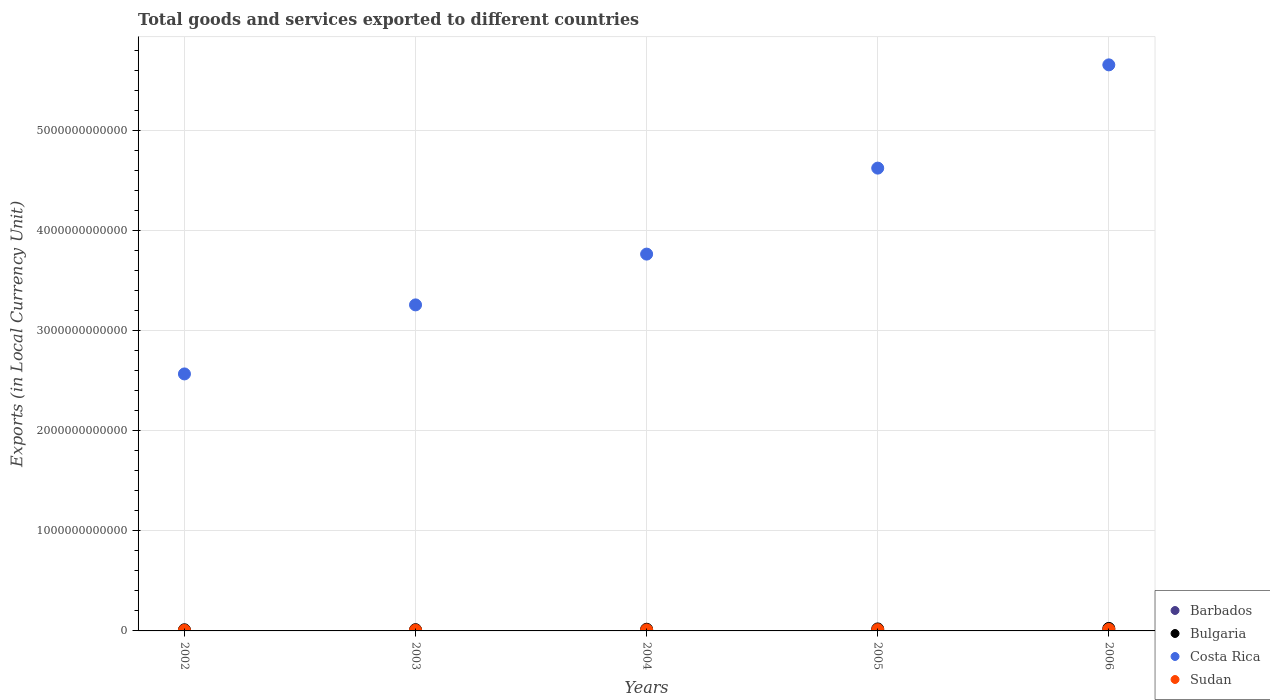Is the number of dotlines equal to the number of legend labels?
Your answer should be compact. Yes. What is the Amount of goods and services exports in Barbados in 2002?
Make the answer very short. 2.42e+09. Across all years, what is the maximum Amount of goods and services exports in Sudan?
Keep it short and to the point. 1.48e+1. Across all years, what is the minimum Amount of goods and services exports in Costa Rica?
Give a very brief answer. 2.57e+12. In which year was the Amount of goods and services exports in Bulgaria maximum?
Provide a succinct answer. 2006. What is the total Amount of goods and services exports in Barbados in the graph?
Offer a very short reply. 1.54e+1. What is the difference between the Amount of goods and services exports in Costa Rica in 2002 and that in 2006?
Keep it short and to the point. -3.09e+12. What is the difference between the Amount of goods and services exports in Costa Rica in 2006 and the Amount of goods and services exports in Bulgaria in 2003?
Your answer should be compact. 5.65e+12. What is the average Amount of goods and services exports in Sudan per year?
Your response must be concise. 9.87e+09. In the year 2004, what is the difference between the Amount of goods and services exports in Bulgaria and Amount of goods and services exports in Barbados?
Keep it short and to the point. 1.40e+1. What is the ratio of the Amount of goods and services exports in Bulgaria in 2005 to that in 2006?
Provide a succinct answer. 0.79. Is the Amount of goods and services exports in Sudan in 2005 less than that in 2006?
Your answer should be very brief. Yes. What is the difference between the highest and the second highest Amount of goods and services exports in Costa Rica?
Your answer should be compact. 1.03e+12. What is the difference between the highest and the lowest Amount of goods and services exports in Bulgaria?
Keep it short and to the point. 1.37e+1. In how many years, is the Amount of goods and services exports in Sudan greater than the average Amount of goods and services exports in Sudan taken over all years?
Your answer should be very brief. 2. Is it the case that in every year, the sum of the Amount of goods and services exports in Bulgaria and Amount of goods and services exports in Barbados  is greater than the sum of Amount of goods and services exports in Costa Rica and Amount of goods and services exports in Sudan?
Your answer should be very brief. Yes. Does the Amount of goods and services exports in Barbados monotonically increase over the years?
Make the answer very short. Yes. Is the Amount of goods and services exports in Sudan strictly greater than the Amount of goods and services exports in Costa Rica over the years?
Give a very brief answer. No. Is the Amount of goods and services exports in Barbados strictly less than the Amount of goods and services exports in Sudan over the years?
Offer a terse response. Yes. How many dotlines are there?
Ensure brevity in your answer.  4. What is the difference between two consecutive major ticks on the Y-axis?
Your response must be concise. 1.00e+12. Are the values on the major ticks of Y-axis written in scientific E-notation?
Your response must be concise. No. Does the graph contain any zero values?
Provide a short and direct response. No. Does the graph contain grids?
Ensure brevity in your answer.  Yes. Where does the legend appear in the graph?
Your answer should be very brief. Bottom right. How many legend labels are there?
Provide a short and direct response. 4. What is the title of the graph?
Your answer should be very brief. Total goods and services exported to different countries. Does "Isle of Man" appear as one of the legend labels in the graph?
Offer a very short reply. No. What is the label or title of the X-axis?
Keep it short and to the point. Years. What is the label or title of the Y-axis?
Give a very brief answer. Exports (in Local Currency Unit). What is the Exports (in Local Currency Unit) in Barbados in 2002?
Make the answer very short. 2.42e+09. What is the Exports (in Local Currency Unit) in Bulgaria in 2002?
Keep it short and to the point. 1.15e+1. What is the Exports (in Local Currency Unit) of Costa Rica in 2002?
Ensure brevity in your answer.  2.57e+12. What is the Exports (in Local Currency Unit) in Sudan in 2002?
Keep it short and to the point. 5.45e+09. What is the Exports (in Local Currency Unit) of Barbados in 2003?
Offer a very short reply. 2.76e+09. What is the Exports (in Local Currency Unit) in Bulgaria in 2003?
Offer a terse response. 1.26e+1. What is the Exports (in Local Currency Unit) of Costa Rica in 2003?
Your response must be concise. 3.26e+12. What is the Exports (in Local Currency Unit) of Sudan in 2003?
Your answer should be very brief. 6.83e+09. What is the Exports (in Local Currency Unit) of Barbados in 2004?
Provide a succinct answer. 2.87e+09. What is the Exports (in Local Currency Unit) of Bulgaria in 2004?
Keep it short and to the point. 1.69e+1. What is the Exports (in Local Currency Unit) in Costa Rica in 2004?
Keep it short and to the point. 3.77e+12. What is the Exports (in Local Currency Unit) in Sudan in 2004?
Offer a very short reply. 9.83e+09. What is the Exports (in Local Currency Unit) in Barbados in 2005?
Keep it short and to the point. 3.42e+09. What is the Exports (in Local Currency Unit) of Bulgaria in 2005?
Offer a very short reply. 2.00e+1. What is the Exports (in Local Currency Unit) of Costa Rica in 2005?
Provide a short and direct response. 4.63e+12. What is the Exports (in Local Currency Unit) in Sudan in 2005?
Ensure brevity in your answer.  1.24e+1. What is the Exports (in Local Currency Unit) of Barbados in 2006?
Keep it short and to the point. 3.88e+09. What is the Exports (in Local Currency Unit) in Bulgaria in 2006?
Your response must be concise. 2.52e+1. What is the Exports (in Local Currency Unit) of Costa Rica in 2006?
Ensure brevity in your answer.  5.66e+12. What is the Exports (in Local Currency Unit) of Sudan in 2006?
Make the answer very short. 1.48e+1. Across all years, what is the maximum Exports (in Local Currency Unit) of Barbados?
Your answer should be very brief. 3.88e+09. Across all years, what is the maximum Exports (in Local Currency Unit) in Bulgaria?
Your answer should be very brief. 2.52e+1. Across all years, what is the maximum Exports (in Local Currency Unit) in Costa Rica?
Give a very brief answer. 5.66e+12. Across all years, what is the maximum Exports (in Local Currency Unit) of Sudan?
Keep it short and to the point. 1.48e+1. Across all years, what is the minimum Exports (in Local Currency Unit) in Barbados?
Your answer should be compact. 2.42e+09. Across all years, what is the minimum Exports (in Local Currency Unit) in Bulgaria?
Provide a short and direct response. 1.15e+1. Across all years, what is the minimum Exports (in Local Currency Unit) in Costa Rica?
Your answer should be compact. 2.57e+12. Across all years, what is the minimum Exports (in Local Currency Unit) in Sudan?
Provide a short and direct response. 5.45e+09. What is the total Exports (in Local Currency Unit) in Barbados in the graph?
Make the answer very short. 1.54e+1. What is the total Exports (in Local Currency Unit) of Bulgaria in the graph?
Ensure brevity in your answer.  8.61e+1. What is the total Exports (in Local Currency Unit) of Costa Rica in the graph?
Your answer should be compact. 1.99e+13. What is the total Exports (in Local Currency Unit) in Sudan in the graph?
Ensure brevity in your answer.  4.93e+1. What is the difference between the Exports (in Local Currency Unit) of Barbados in 2002 and that in 2003?
Offer a very short reply. -3.36e+08. What is the difference between the Exports (in Local Currency Unit) in Bulgaria in 2002 and that in 2003?
Offer a terse response. -1.15e+09. What is the difference between the Exports (in Local Currency Unit) in Costa Rica in 2002 and that in 2003?
Your answer should be compact. -6.90e+11. What is the difference between the Exports (in Local Currency Unit) of Sudan in 2002 and that in 2003?
Provide a succinct answer. -1.38e+09. What is the difference between the Exports (in Local Currency Unit) in Barbados in 2002 and that in 2004?
Ensure brevity in your answer.  -4.50e+08. What is the difference between the Exports (in Local Currency Unit) in Bulgaria in 2002 and that in 2004?
Your response must be concise. -5.41e+09. What is the difference between the Exports (in Local Currency Unit) in Costa Rica in 2002 and that in 2004?
Keep it short and to the point. -1.20e+12. What is the difference between the Exports (in Local Currency Unit) in Sudan in 2002 and that in 2004?
Ensure brevity in your answer.  -4.38e+09. What is the difference between the Exports (in Local Currency Unit) of Barbados in 2002 and that in 2005?
Your answer should be very brief. -1.00e+09. What is the difference between the Exports (in Local Currency Unit) in Bulgaria in 2002 and that in 2005?
Make the answer very short. -8.53e+09. What is the difference between the Exports (in Local Currency Unit) in Costa Rica in 2002 and that in 2005?
Offer a terse response. -2.06e+12. What is the difference between the Exports (in Local Currency Unit) of Sudan in 2002 and that in 2005?
Your response must be concise. -6.94e+09. What is the difference between the Exports (in Local Currency Unit) of Barbados in 2002 and that in 2006?
Offer a very short reply. -1.46e+09. What is the difference between the Exports (in Local Currency Unit) of Bulgaria in 2002 and that in 2006?
Give a very brief answer. -1.37e+1. What is the difference between the Exports (in Local Currency Unit) of Costa Rica in 2002 and that in 2006?
Your answer should be very brief. -3.09e+12. What is the difference between the Exports (in Local Currency Unit) in Sudan in 2002 and that in 2006?
Provide a short and direct response. -9.39e+09. What is the difference between the Exports (in Local Currency Unit) in Barbados in 2003 and that in 2004?
Keep it short and to the point. -1.14e+08. What is the difference between the Exports (in Local Currency Unit) of Bulgaria in 2003 and that in 2004?
Your answer should be very brief. -4.27e+09. What is the difference between the Exports (in Local Currency Unit) in Costa Rica in 2003 and that in 2004?
Your answer should be very brief. -5.08e+11. What is the difference between the Exports (in Local Currency Unit) of Sudan in 2003 and that in 2004?
Offer a terse response. -3.00e+09. What is the difference between the Exports (in Local Currency Unit) of Barbados in 2003 and that in 2005?
Offer a terse response. -6.65e+08. What is the difference between the Exports (in Local Currency Unit) of Bulgaria in 2003 and that in 2005?
Offer a terse response. -7.39e+09. What is the difference between the Exports (in Local Currency Unit) of Costa Rica in 2003 and that in 2005?
Offer a very short reply. -1.37e+12. What is the difference between the Exports (in Local Currency Unit) of Sudan in 2003 and that in 2005?
Your answer should be compact. -5.56e+09. What is the difference between the Exports (in Local Currency Unit) of Barbados in 2003 and that in 2006?
Keep it short and to the point. -1.12e+09. What is the difference between the Exports (in Local Currency Unit) in Bulgaria in 2003 and that in 2006?
Your answer should be very brief. -1.26e+1. What is the difference between the Exports (in Local Currency Unit) of Costa Rica in 2003 and that in 2006?
Keep it short and to the point. -2.40e+12. What is the difference between the Exports (in Local Currency Unit) in Sudan in 2003 and that in 2006?
Your response must be concise. -8.01e+09. What is the difference between the Exports (in Local Currency Unit) in Barbados in 2004 and that in 2005?
Provide a succinct answer. -5.51e+08. What is the difference between the Exports (in Local Currency Unit) of Bulgaria in 2004 and that in 2005?
Your answer should be compact. -3.12e+09. What is the difference between the Exports (in Local Currency Unit) of Costa Rica in 2004 and that in 2005?
Offer a very short reply. -8.60e+11. What is the difference between the Exports (in Local Currency Unit) of Sudan in 2004 and that in 2005?
Provide a short and direct response. -2.56e+09. What is the difference between the Exports (in Local Currency Unit) of Barbados in 2004 and that in 2006?
Your answer should be compact. -1.00e+09. What is the difference between the Exports (in Local Currency Unit) in Bulgaria in 2004 and that in 2006?
Offer a very short reply. -8.31e+09. What is the difference between the Exports (in Local Currency Unit) of Costa Rica in 2004 and that in 2006?
Your answer should be compact. -1.89e+12. What is the difference between the Exports (in Local Currency Unit) of Sudan in 2004 and that in 2006?
Ensure brevity in your answer.  -5.01e+09. What is the difference between the Exports (in Local Currency Unit) of Barbados in 2005 and that in 2006?
Provide a succinct answer. -4.54e+08. What is the difference between the Exports (in Local Currency Unit) of Bulgaria in 2005 and that in 2006?
Provide a succinct answer. -5.19e+09. What is the difference between the Exports (in Local Currency Unit) of Costa Rica in 2005 and that in 2006?
Your response must be concise. -1.03e+12. What is the difference between the Exports (in Local Currency Unit) in Sudan in 2005 and that in 2006?
Keep it short and to the point. -2.44e+09. What is the difference between the Exports (in Local Currency Unit) of Barbados in 2002 and the Exports (in Local Currency Unit) of Bulgaria in 2003?
Keep it short and to the point. -1.02e+1. What is the difference between the Exports (in Local Currency Unit) in Barbados in 2002 and the Exports (in Local Currency Unit) in Costa Rica in 2003?
Provide a succinct answer. -3.26e+12. What is the difference between the Exports (in Local Currency Unit) of Barbados in 2002 and the Exports (in Local Currency Unit) of Sudan in 2003?
Your answer should be compact. -4.41e+09. What is the difference between the Exports (in Local Currency Unit) of Bulgaria in 2002 and the Exports (in Local Currency Unit) of Costa Rica in 2003?
Your answer should be compact. -3.25e+12. What is the difference between the Exports (in Local Currency Unit) in Bulgaria in 2002 and the Exports (in Local Currency Unit) in Sudan in 2003?
Your response must be concise. 4.63e+09. What is the difference between the Exports (in Local Currency Unit) of Costa Rica in 2002 and the Exports (in Local Currency Unit) of Sudan in 2003?
Provide a succinct answer. 2.56e+12. What is the difference between the Exports (in Local Currency Unit) in Barbados in 2002 and the Exports (in Local Currency Unit) in Bulgaria in 2004?
Make the answer very short. -1.45e+1. What is the difference between the Exports (in Local Currency Unit) of Barbados in 2002 and the Exports (in Local Currency Unit) of Costa Rica in 2004?
Offer a terse response. -3.76e+12. What is the difference between the Exports (in Local Currency Unit) of Barbados in 2002 and the Exports (in Local Currency Unit) of Sudan in 2004?
Provide a succinct answer. -7.41e+09. What is the difference between the Exports (in Local Currency Unit) of Bulgaria in 2002 and the Exports (in Local Currency Unit) of Costa Rica in 2004?
Your response must be concise. -3.76e+12. What is the difference between the Exports (in Local Currency Unit) in Bulgaria in 2002 and the Exports (in Local Currency Unit) in Sudan in 2004?
Ensure brevity in your answer.  1.64e+09. What is the difference between the Exports (in Local Currency Unit) in Costa Rica in 2002 and the Exports (in Local Currency Unit) in Sudan in 2004?
Provide a succinct answer. 2.56e+12. What is the difference between the Exports (in Local Currency Unit) of Barbados in 2002 and the Exports (in Local Currency Unit) of Bulgaria in 2005?
Provide a succinct answer. -1.76e+1. What is the difference between the Exports (in Local Currency Unit) in Barbados in 2002 and the Exports (in Local Currency Unit) in Costa Rica in 2005?
Provide a succinct answer. -4.62e+12. What is the difference between the Exports (in Local Currency Unit) in Barbados in 2002 and the Exports (in Local Currency Unit) in Sudan in 2005?
Provide a short and direct response. -9.97e+09. What is the difference between the Exports (in Local Currency Unit) in Bulgaria in 2002 and the Exports (in Local Currency Unit) in Costa Rica in 2005?
Offer a terse response. -4.61e+12. What is the difference between the Exports (in Local Currency Unit) of Bulgaria in 2002 and the Exports (in Local Currency Unit) of Sudan in 2005?
Make the answer very short. -9.29e+08. What is the difference between the Exports (in Local Currency Unit) in Costa Rica in 2002 and the Exports (in Local Currency Unit) in Sudan in 2005?
Offer a terse response. 2.56e+12. What is the difference between the Exports (in Local Currency Unit) in Barbados in 2002 and the Exports (in Local Currency Unit) in Bulgaria in 2006?
Provide a short and direct response. -2.28e+1. What is the difference between the Exports (in Local Currency Unit) in Barbados in 2002 and the Exports (in Local Currency Unit) in Costa Rica in 2006?
Make the answer very short. -5.66e+12. What is the difference between the Exports (in Local Currency Unit) of Barbados in 2002 and the Exports (in Local Currency Unit) of Sudan in 2006?
Keep it short and to the point. -1.24e+1. What is the difference between the Exports (in Local Currency Unit) of Bulgaria in 2002 and the Exports (in Local Currency Unit) of Costa Rica in 2006?
Offer a terse response. -5.65e+12. What is the difference between the Exports (in Local Currency Unit) of Bulgaria in 2002 and the Exports (in Local Currency Unit) of Sudan in 2006?
Keep it short and to the point. -3.37e+09. What is the difference between the Exports (in Local Currency Unit) in Costa Rica in 2002 and the Exports (in Local Currency Unit) in Sudan in 2006?
Keep it short and to the point. 2.55e+12. What is the difference between the Exports (in Local Currency Unit) of Barbados in 2003 and the Exports (in Local Currency Unit) of Bulgaria in 2004?
Offer a very short reply. -1.41e+1. What is the difference between the Exports (in Local Currency Unit) in Barbados in 2003 and the Exports (in Local Currency Unit) in Costa Rica in 2004?
Offer a very short reply. -3.76e+12. What is the difference between the Exports (in Local Currency Unit) of Barbados in 2003 and the Exports (in Local Currency Unit) of Sudan in 2004?
Provide a succinct answer. -7.07e+09. What is the difference between the Exports (in Local Currency Unit) in Bulgaria in 2003 and the Exports (in Local Currency Unit) in Costa Rica in 2004?
Offer a terse response. -3.75e+12. What is the difference between the Exports (in Local Currency Unit) in Bulgaria in 2003 and the Exports (in Local Currency Unit) in Sudan in 2004?
Your answer should be very brief. 2.78e+09. What is the difference between the Exports (in Local Currency Unit) of Costa Rica in 2003 and the Exports (in Local Currency Unit) of Sudan in 2004?
Ensure brevity in your answer.  3.25e+12. What is the difference between the Exports (in Local Currency Unit) in Barbados in 2003 and the Exports (in Local Currency Unit) in Bulgaria in 2005?
Keep it short and to the point. -1.72e+1. What is the difference between the Exports (in Local Currency Unit) in Barbados in 2003 and the Exports (in Local Currency Unit) in Costa Rica in 2005?
Your answer should be very brief. -4.62e+12. What is the difference between the Exports (in Local Currency Unit) in Barbados in 2003 and the Exports (in Local Currency Unit) in Sudan in 2005?
Keep it short and to the point. -9.63e+09. What is the difference between the Exports (in Local Currency Unit) in Bulgaria in 2003 and the Exports (in Local Currency Unit) in Costa Rica in 2005?
Your answer should be very brief. -4.61e+12. What is the difference between the Exports (in Local Currency Unit) of Bulgaria in 2003 and the Exports (in Local Currency Unit) of Sudan in 2005?
Make the answer very short. 2.17e+08. What is the difference between the Exports (in Local Currency Unit) in Costa Rica in 2003 and the Exports (in Local Currency Unit) in Sudan in 2005?
Your response must be concise. 3.25e+12. What is the difference between the Exports (in Local Currency Unit) of Barbados in 2003 and the Exports (in Local Currency Unit) of Bulgaria in 2006?
Your response must be concise. -2.24e+1. What is the difference between the Exports (in Local Currency Unit) in Barbados in 2003 and the Exports (in Local Currency Unit) in Costa Rica in 2006?
Offer a terse response. -5.66e+12. What is the difference between the Exports (in Local Currency Unit) in Barbados in 2003 and the Exports (in Local Currency Unit) in Sudan in 2006?
Ensure brevity in your answer.  -1.21e+1. What is the difference between the Exports (in Local Currency Unit) of Bulgaria in 2003 and the Exports (in Local Currency Unit) of Costa Rica in 2006?
Offer a very short reply. -5.65e+12. What is the difference between the Exports (in Local Currency Unit) of Bulgaria in 2003 and the Exports (in Local Currency Unit) of Sudan in 2006?
Your answer should be compact. -2.23e+09. What is the difference between the Exports (in Local Currency Unit) in Costa Rica in 2003 and the Exports (in Local Currency Unit) in Sudan in 2006?
Keep it short and to the point. 3.24e+12. What is the difference between the Exports (in Local Currency Unit) in Barbados in 2004 and the Exports (in Local Currency Unit) in Bulgaria in 2005?
Your answer should be compact. -1.71e+1. What is the difference between the Exports (in Local Currency Unit) of Barbados in 2004 and the Exports (in Local Currency Unit) of Costa Rica in 2005?
Your response must be concise. -4.62e+12. What is the difference between the Exports (in Local Currency Unit) of Barbados in 2004 and the Exports (in Local Currency Unit) of Sudan in 2005?
Make the answer very short. -9.52e+09. What is the difference between the Exports (in Local Currency Unit) of Bulgaria in 2004 and the Exports (in Local Currency Unit) of Costa Rica in 2005?
Offer a very short reply. -4.61e+12. What is the difference between the Exports (in Local Currency Unit) in Bulgaria in 2004 and the Exports (in Local Currency Unit) in Sudan in 2005?
Your answer should be compact. 4.48e+09. What is the difference between the Exports (in Local Currency Unit) in Costa Rica in 2004 and the Exports (in Local Currency Unit) in Sudan in 2005?
Keep it short and to the point. 3.75e+12. What is the difference between the Exports (in Local Currency Unit) in Barbados in 2004 and the Exports (in Local Currency Unit) in Bulgaria in 2006?
Provide a succinct answer. -2.23e+1. What is the difference between the Exports (in Local Currency Unit) of Barbados in 2004 and the Exports (in Local Currency Unit) of Costa Rica in 2006?
Keep it short and to the point. -5.66e+12. What is the difference between the Exports (in Local Currency Unit) in Barbados in 2004 and the Exports (in Local Currency Unit) in Sudan in 2006?
Give a very brief answer. -1.20e+1. What is the difference between the Exports (in Local Currency Unit) of Bulgaria in 2004 and the Exports (in Local Currency Unit) of Costa Rica in 2006?
Your response must be concise. -5.64e+12. What is the difference between the Exports (in Local Currency Unit) in Bulgaria in 2004 and the Exports (in Local Currency Unit) in Sudan in 2006?
Your answer should be compact. 2.04e+09. What is the difference between the Exports (in Local Currency Unit) of Costa Rica in 2004 and the Exports (in Local Currency Unit) of Sudan in 2006?
Offer a terse response. 3.75e+12. What is the difference between the Exports (in Local Currency Unit) of Barbados in 2005 and the Exports (in Local Currency Unit) of Bulgaria in 2006?
Make the answer very short. -2.18e+1. What is the difference between the Exports (in Local Currency Unit) in Barbados in 2005 and the Exports (in Local Currency Unit) in Costa Rica in 2006?
Your answer should be compact. -5.66e+12. What is the difference between the Exports (in Local Currency Unit) of Barbados in 2005 and the Exports (in Local Currency Unit) of Sudan in 2006?
Ensure brevity in your answer.  -1.14e+1. What is the difference between the Exports (in Local Currency Unit) in Bulgaria in 2005 and the Exports (in Local Currency Unit) in Costa Rica in 2006?
Ensure brevity in your answer.  -5.64e+12. What is the difference between the Exports (in Local Currency Unit) in Bulgaria in 2005 and the Exports (in Local Currency Unit) in Sudan in 2006?
Keep it short and to the point. 5.16e+09. What is the difference between the Exports (in Local Currency Unit) of Costa Rica in 2005 and the Exports (in Local Currency Unit) of Sudan in 2006?
Your answer should be compact. 4.61e+12. What is the average Exports (in Local Currency Unit) in Barbados per year?
Make the answer very short. 3.07e+09. What is the average Exports (in Local Currency Unit) in Bulgaria per year?
Provide a succinct answer. 1.72e+1. What is the average Exports (in Local Currency Unit) of Costa Rica per year?
Keep it short and to the point. 3.98e+12. What is the average Exports (in Local Currency Unit) in Sudan per year?
Give a very brief answer. 9.87e+09. In the year 2002, what is the difference between the Exports (in Local Currency Unit) of Barbados and Exports (in Local Currency Unit) of Bulgaria?
Offer a terse response. -9.04e+09. In the year 2002, what is the difference between the Exports (in Local Currency Unit) in Barbados and Exports (in Local Currency Unit) in Costa Rica?
Provide a short and direct response. -2.57e+12. In the year 2002, what is the difference between the Exports (in Local Currency Unit) of Barbados and Exports (in Local Currency Unit) of Sudan?
Make the answer very short. -3.03e+09. In the year 2002, what is the difference between the Exports (in Local Currency Unit) of Bulgaria and Exports (in Local Currency Unit) of Costa Rica?
Make the answer very short. -2.56e+12. In the year 2002, what is the difference between the Exports (in Local Currency Unit) of Bulgaria and Exports (in Local Currency Unit) of Sudan?
Offer a terse response. 6.01e+09. In the year 2002, what is the difference between the Exports (in Local Currency Unit) of Costa Rica and Exports (in Local Currency Unit) of Sudan?
Offer a very short reply. 2.56e+12. In the year 2003, what is the difference between the Exports (in Local Currency Unit) in Barbados and Exports (in Local Currency Unit) in Bulgaria?
Give a very brief answer. -9.85e+09. In the year 2003, what is the difference between the Exports (in Local Currency Unit) of Barbados and Exports (in Local Currency Unit) of Costa Rica?
Offer a very short reply. -3.26e+12. In the year 2003, what is the difference between the Exports (in Local Currency Unit) of Barbados and Exports (in Local Currency Unit) of Sudan?
Your answer should be compact. -4.07e+09. In the year 2003, what is the difference between the Exports (in Local Currency Unit) in Bulgaria and Exports (in Local Currency Unit) in Costa Rica?
Your answer should be compact. -3.25e+12. In the year 2003, what is the difference between the Exports (in Local Currency Unit) in Bulgaria and Exports (in Local Currency Unit) in Sudan?
Provide a short and direct response. 5.78e+09. In the year 2003, what is the difference between the Exports (in Local Currency Unit) of Costa Rica and Exports (in Local Currency Unit) of Sudan?
Offer a very short reply. 3.25e+12. In the year 2004, what is the difference between the Exports (in Local Currency Unit) in Barbados and Exports (in Local Currency Unit) in Bulgaria?
Ensure brevity in your answer.  -1.40e+1. In the year 2004, what is the difference between the Exports (in Local Currency Unit) of Barbados and Exports (in Local Currency Unit) of Costa Rica?
Your response must be concise. -3.76e+12. In the year 2004, what is the difference between the Exports (in Local Currency Unit) in Barbados and Exports (in Local Currency Unit) in Sudan?
Make the answer very short. -6.96e+09. In the year 2004, what is the difference between the Exports (in Local Currency Unit) of Bulgaria and Exports (in Local Currency Unit) of Costa Rica?
Your answer should be very brief. -3.75e+12. In the year 2004, what is the difference between the Exports (in Local Currency Unit) of Bulgaria and Exports (in Local Currency Unit) of Sudan?
Your response must be concise. 7.05e+09. In the year 2004, what is the difference between the Exports (in Local Currency Unit) of Costa Rica and Exports (in Local Currency Unit) of Sudan?
Make the answer very short. 3.76e+12. In the year 2005, what is the difference between the Exports (in Local Currency Unit) in Barbados and Exports (in Local Currency Unit) in Bulgaria?
Offer a very short reply. -1.66e+1. In the year 2005, what is the difference between the Exports (in Local Currency Unit) in Barbados and Exports (in Local Currency Unit) in Costa Rica?
Your answer should be very brief. -4.62e+12. In the year 2005, what is the difference between the Exports (in Local Currency Unit) of Barbados and Exports (in Local Currency Unit) of Sudan?
Provide a short and direct response. -8.97e+09. In the year 2005, what is the difference between the Exports (in Local Currency Unit) of Bulgaria and Exports (in Local Currency Unit) of Costa Rica?
Provide a short and direct response. -4.61e+12. In the year 2005, what is the difference between the Exports (in Local Currency Unit) in Bulgaria and Exports (in Local Currency Unit) in Sudan?
Provide a succinct answer. 7.60e+09. In the year 2005, what is the difference between the Exports (in Local Currency Unit) of Costa Rica and Exports (in Local Currency Unit) of Sudan?
Give a very brief answer. 4.61e+12. In the year 2006, what is the difference between the Exports (in Local Currency Unit) in Barbados and Exports (in Local Currency Unit) in Bulgaria?
Your response must be concise. -2.13e+1. In the year 2006, what is the difference between the Exports (in Local Currency Unit) in Barbados and Exports (in Local Currency Unit) in Costa Rica?
Keep it short and to the point. -5.65e+12. In the year 2006, what is the difference between the Exports (in Local Currency Unit) in Barbados and Exports (in Local Currency Unit) in Sudan?
Make the answer very short. -1.10e+1. In the year 2006, what is the difference between the Exports (in Local Currency Unit) of Bulgaria and Exports (in Local Currency Unit) of Costa Rica?
Provide a succinct answer. -5.63e+12. In the year 2006, what is the difference between the Exports (in Local Currency Unit) in Bulgaria and Exports (in Local Currency Unit) in Sudan?
Give a very brief answer. 1.03e+1. In the year 2006, what is the difference between the Exports (in Local Currency Unit) in Costa Rica and Exports (in Local Currency Unit) in Sudan?
Your response must be concise. 5.64e+12. What is the ratio of the Exports (in Local Currency Unit) of Barbados in 2002 to that in 2003?
Ensure brevity in your answer.  0.88. What is the ratio of the Exports (in Local Currency Unit) in Bulgaria in 2002 to that in 2003?
Offer a terse response. 0.91. What is the ratio of the Exports (in Local Currency Unit) in Costa Rica in 2002 to that in 2003?
Provide a short and direct response. 0.79. What is the ratio of the Exports (in Local Currency Unit) of Sudan in 2002 to that in 2003?
Offer a terse response. 0.8. What is the ratio of the Exports (in Local Currency Unit) of Barbados in 2002 to that in 2004?
Give a very brief answer. 0.84. What is the ratio of the Exports (in Local Currency Unit) of Bulgaria in 2002 to that in 2004?
Provide a short and direct response. 0.68. What is the ratio of the Exports (in Local Currency Unit) of Costa Rica in 2002 to that in 2004?
Keep it short and to the point. 0.68. What is the ratio of the Exports (in Local Currency Unit) of Sudan in 2002 to that in 2004?
Offer a terse response. 0.55. What is the ratio of the Exports (in Local Currency Unit) of Barbados in 2002 to that in 2005?
Your answer should be very brief. 0.71. What is the ratio of the Exports (in Local Currency Unit) in Bulgaria in 2002 to that in 2005?
Keep it short and to the point. 0.57. What is the ratio of the Exports (in Local Currency Unit) in Costa Rica in 2002 to that in 2005?
Offer a very short reply. 0.56. What is the ratio of the Exports (in Local Currency Unit) in Sudan in 2002 to that in 2005?
Provide a succinct answer. 0.44. What is the ratio of the Exports (in Local Currency Unit) of Barbados in 2002 to that in 2006?
Offer a very short reply. 0.62. What is the ratio of the Exports (in Local Currency Unit) of Bulgaria in 2002 to that in 2006?
Give a very brief answer. 0.46. What is the ratio of the Exports (in Local Currency Unit) in Costa Rica in 2002 to that in 2006?
Your response must be concise. 0.45. What is the ratio of the Exports (in Local Currency Unit) of Sudan in 2002 to that in 2006?
Your answer should be very brief. 0.37. What is the ratio of the Exports (in Local Currency Unit) of Barbados in 2003 to that in 2004?
Your response must be concise. 0.96. What is the ratio of the Exports (in Local Currency Unit) in Bulgaria in 2003 to that in 2004?
Make the answer very short. 0.75. What is the ratio of the Exports (in Local Currency Unit) in Costa Rica in 2003 to that in 2004?
Keep it short and to the point. 0.87. What is the ratio of the Exports (in Local Currency Unit) in Sudan in 2003 to that in 2004?
Keep it short and to the point. 0.69. What is the ratio of the Exports (in Local Currency Unit) in Barbados in 2003 to that in 2005?
Provide a succinct answer. 0.81. What is the ratio of the Exports (in Local Currency Unit) of Bulgaria in 2003 to that in 2005?
Provide a short and direct response. 0.63. What is the ratio of the Exports (in Local Currency Unit) of Costa Rica in 2003 to that in 2005?
Your answer should be very brief. 0.7. What is the ratio of the Exports (in Local Currency Unit) of Sudan in 2003 to that in 2005?
Ensure brevity in your answer.  0.55. What is the ratio of the Exports (in Local Currency Unit) in Barbados in 2003 to that in 2006?
Give a very brief answer. 0.71. What is the ratio of the Exports (in Local Currency Unit) of Bulgaria in 2003 to that in 2006?
Provide a short and direct response. 0.5. What is the ratio of the Exports (in Local Currency Unit) in Costa Rica in 2003 to that in 2006?
Provide a short and direct response. 0.58. What is the ratio of the Exports (in Local Currency Unit) in Sudan in 2003 to that in 2006?
Keep it short and to the point. 0.46. What is the ratio of the Exports (in Local Currency Unit) of Barbados in 2004 to that in 2005?
Offer a very short reply. 0.84. What is the ratio of the Exports (in Local Currency Unit) of Bulgaria in 2004 to that in 2005?
Your answer should be very brief. 0.84. What is the ratio of the Exports (in Local Currency Unit) of Costa Rica in 2004 to that in 2005?
Make the answer very short. 0.81. What is the ratio of the Exports (in Local Currency Unit) of Sudan in 2004 to that in 2005?
Offer a very short reply. 0.79. What is the ratio of the Exports (in Local Currency Unit) in Barbados in 2004 to that in 2006?
Keep it short and to the point. 0.74. What is the ratio of the Exports (in Local Currency Unit) in Bulgaria in 2004 to that in 2006?
Offer a very short reply. 0.67. What is the ratio of the Exports (in Local Currency Unit) in Costa Rica in 2004 to that in 2006?
Give a very brief answer. 0.67. What is the ratio of the Exports (in Local Currency Unit) of Sudan in 2004 to that in 2006?
Your response must be concise. 0.66. What is the ratio of the Exports (in Local Currency Unit) of Barbados in 2005 to that in 2006?
Offer a terse response. 0.88. What is the ratio of the Exports (in Local Currency Unit) of Bulgaria in 2005 to that in 2006?
Your response must be concise. 0.79. What is the ratio of the Exports (in Local Currency Unit) of Costa Rica in 2005 to that in 2006?
Ensure brevity in your answer.  0.82. What is the ratio of the Exports (in Local Currency Unit) of Sudan in 2005 to that in 2006?
Make the answer very short. 0.84. What is the difference between the highest and the second highest Exports (in Local Currency Unit) of Barbados?
Offer a terse response. 4.54e+08. What is the difference between the highest and the second highest Exports (in Local Currency Unit) in Bulgaria?
Provide a short and direct response. 5.19e+09. What is the difference between the highest and the second highest Exports (in Local Currency Unit) of Costa Rica?
Your answer should be very brief. 1.03e+12. What is the difference between the highest and the second highest Exports (in Local Currency Unit) of Sudan?
Give a very brief answer. 2.44e+09. What is the difference between the highest and the lowest Exports (in Local Currency Unit) of Barbados?
Make the answer very short. 1.46e+09. What is the difference between the highest and the lowest Exports (in Local Currency Unit) of Bulgaria?
Offer a very short reply. 1.37e+1. What is the difference between the highest and the lowest Exports (in Local Currency Unit) of Costa Rica?
Your answer should be very brief. 3.09e+12. What is the difference between the highest and the lowest Exports (in Local Currency Unit) in Sudan?
Give a very brief answer. 9.39e+09. 